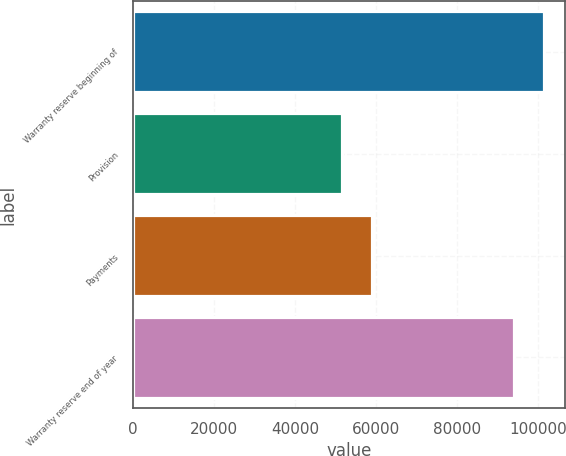Convert chart. <chart><loc_0><loc_0><loc_500><loc_500><bar_chart><fcel>Warranty reserve beginning of<fcel>Provision<fcel>Payments<fcel>Warranty reserve end of year<nl><fcel>101507<fcel>51668<fcel>59115<fcel>94060<nl></chart> 